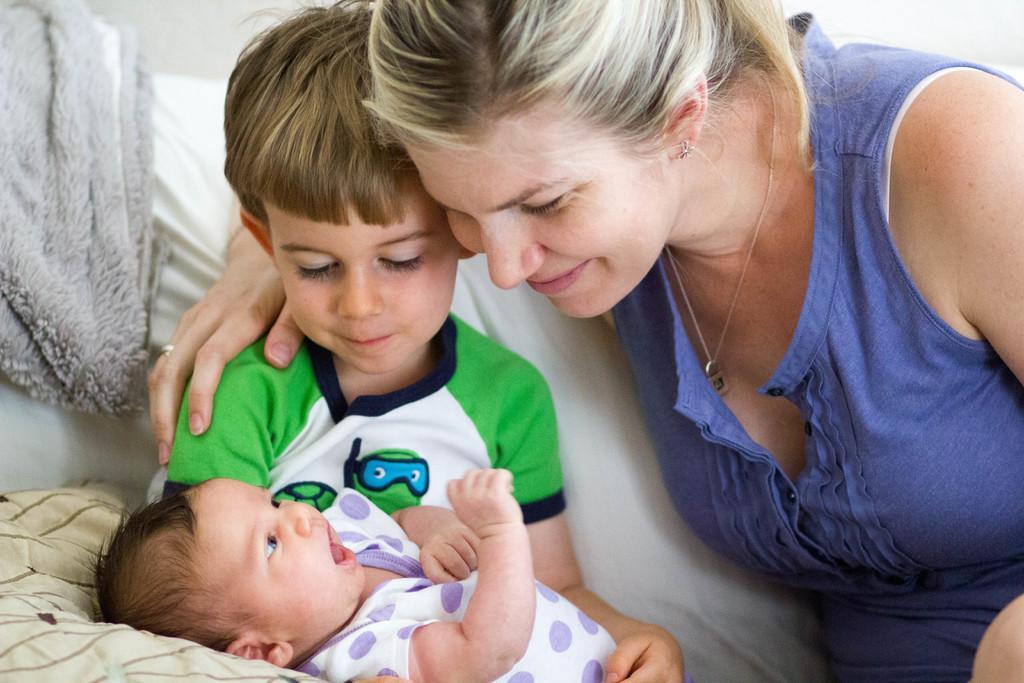Could you give a brief overview of what you see in this image? In this picture I can see a woman and I can see a boy holding a baby and I can see a cloth on the left side and looks like a pillow on the bottom left corner. 